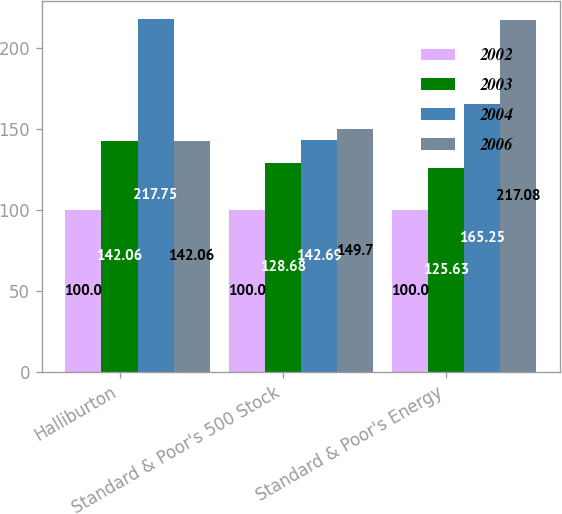Convert chart to OTSL. <chart><loc_0><loc_0><loc_500><loc_500><stacked_bar_chart><ecel><fcel>Halliburton<fcel>Standard & Poor's 500 Stock<fcel>Standard & Poor's Energy<nl><fcel>2002<fcel>100<fcel>100<fcel>100<nl><fcel>2003<fcel>142.06<fcel>128.68<fcel>125.63<nl><fcel>2004<fcel>217.75<fcel>142.69<fcel>165.25<nl><fcel>2006<fcel>142.06<fcel>149.7<fcel>217.08<nl></chart> 